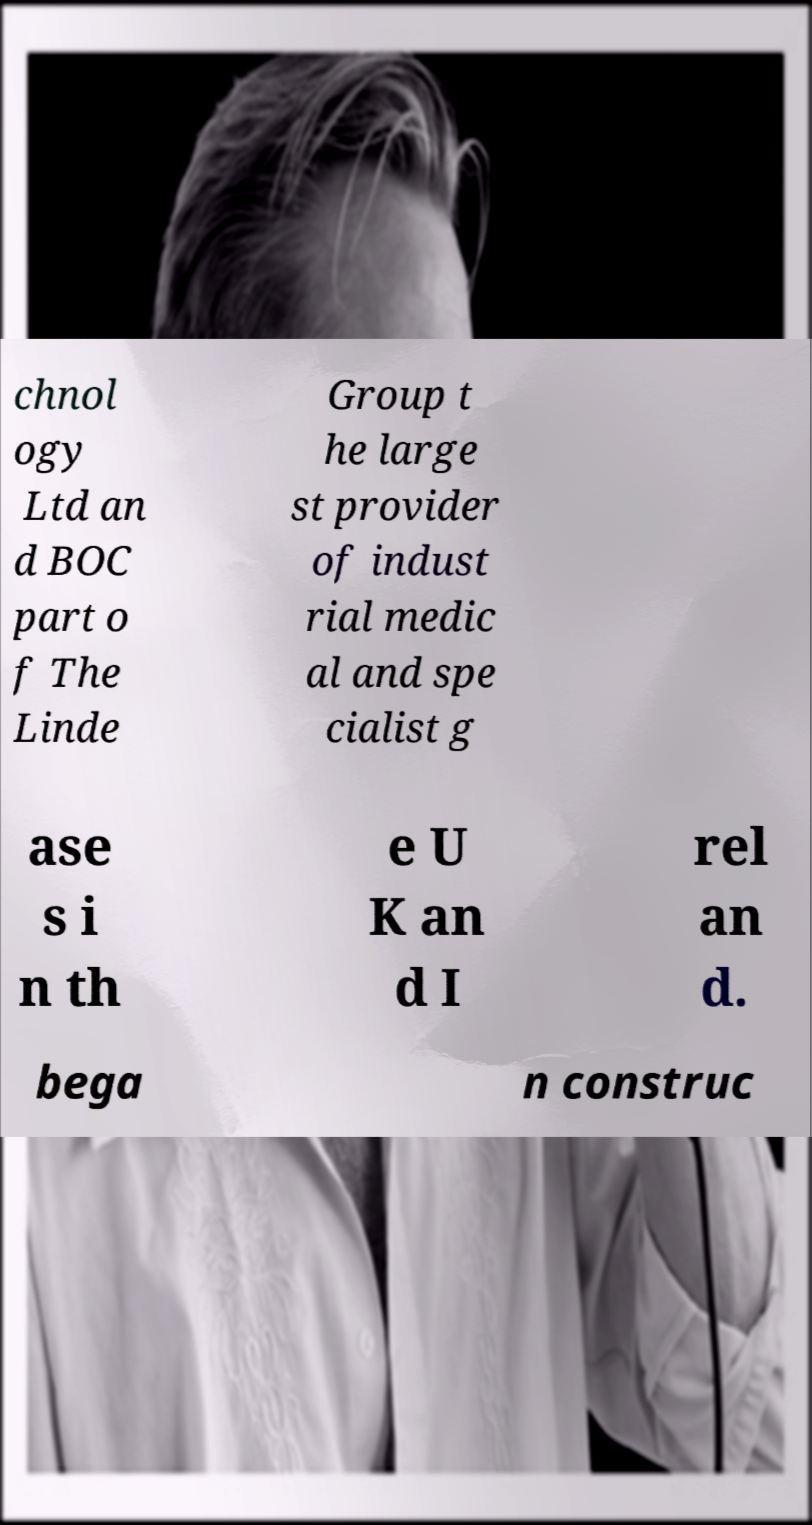What messages or text are displayed in this image? I need them in a readable, typed format. chnol ogy Ltd an d BOC part o f The Linde Group t he large st provider of indust rial medic al and spe cialist g ase s i n th e U K an d I rel an d. bega n construc 